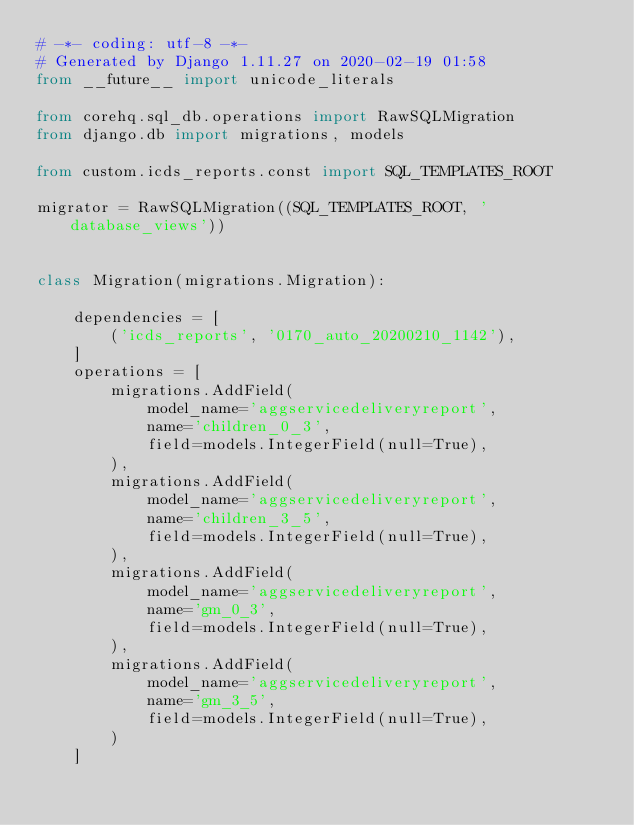<code> <loc_0><loc_0><loc_500><loc_500><_Python_># -*- coding: utf-8 -*-
# Generated by Django 1.11.27 on 2020-02-19 01:58
from __future__ import unicode_literals

from corehq.sql_db.operations import RawSQLMigration
from django.db import migrations, models

from custom.icds_reports.const import SQL_TEMPLATES_ROOT

migrator = RawSQLMigration((SQL_TEMPLATES_ROOT, 'database_views'))


class Migration(migrations.Migration):

    dependencies = [
        ('icds_reports', '0170_auto_20200210_1142'),
    ]
    operations = [
        migrations.AddField(
            model_name='aggservicedeliveryreport',
            name='children_0_3',
            field=models.IntegerField(null=True),
        ),
        migrations.AddField(
            model_name='aggservicedeliveryreport',
            name='children_3_5',
            field=models.IntegerField(null=True),
        ),
        migrations.AddField(
            model_name='aggservicedeliveryreport',
            name='gm_0_3',
            field=models.IntegerField(null=True),
        ),
        migrations.AddField(
            model_name='aggservicedeliveryreport',
            name='gm_3_5',
            field=models.IntegerField(null=True),
        )
    ]
</code> 